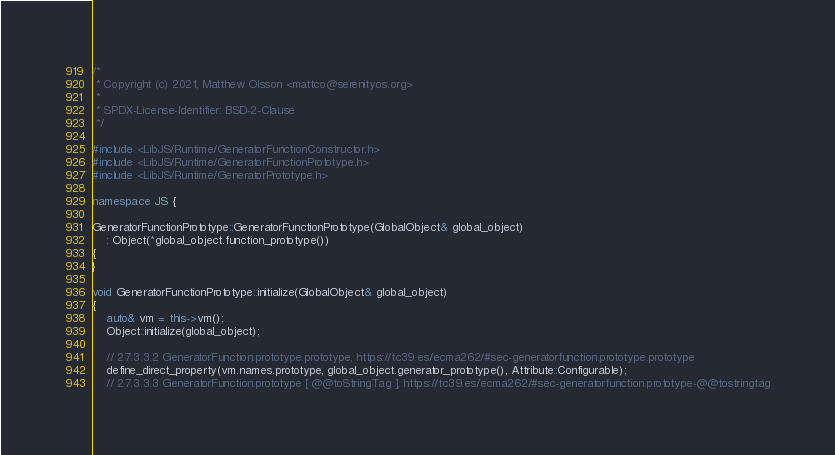<code> <loc_0><loc_0><loc_500><loc_500><_C++_>/*
 * Copyright (c) 2021, Matthew Olsson <mattco@serenityos.org>
 *
 * SPDX-License-Identifier: BSD-2-Clause
 */

#include <LibJS/Runtime/GeneratorFunctionConstructor.h>
#include <LibJS/Runtime/GeneratorFunctionPrototype.h>
#include <LibJS/Runtime/GeneratorPrototype.h>

namespace JS {

GeneratorFunctionPrototype::GeneratorFunctionPrototype(GlobalObject& global_object)
    : Object(*global_object.function_prototype())
{
}

void GeneratorFunctionPrototype::initialize(GlobalObject& global_object)
{
    auto& vm = this->vm();
    Object::initialize(global_object);

    // 27.3.3.2 GeneratorFunction.prototype.prototype, https://tc39.es/ecma262/#sec-generatorfunction.prototype.prototype
    define_direct_property(vm.names.prototype, global_object.generator_prototype(), Attribute::Configurable);
    // 27.3.3.3 GeneratorFunction.prototype [ @@toStringTag ], https://tc39.es/ecma262/#sec-generatorfunction.prototype-@@tostringtag</code> 